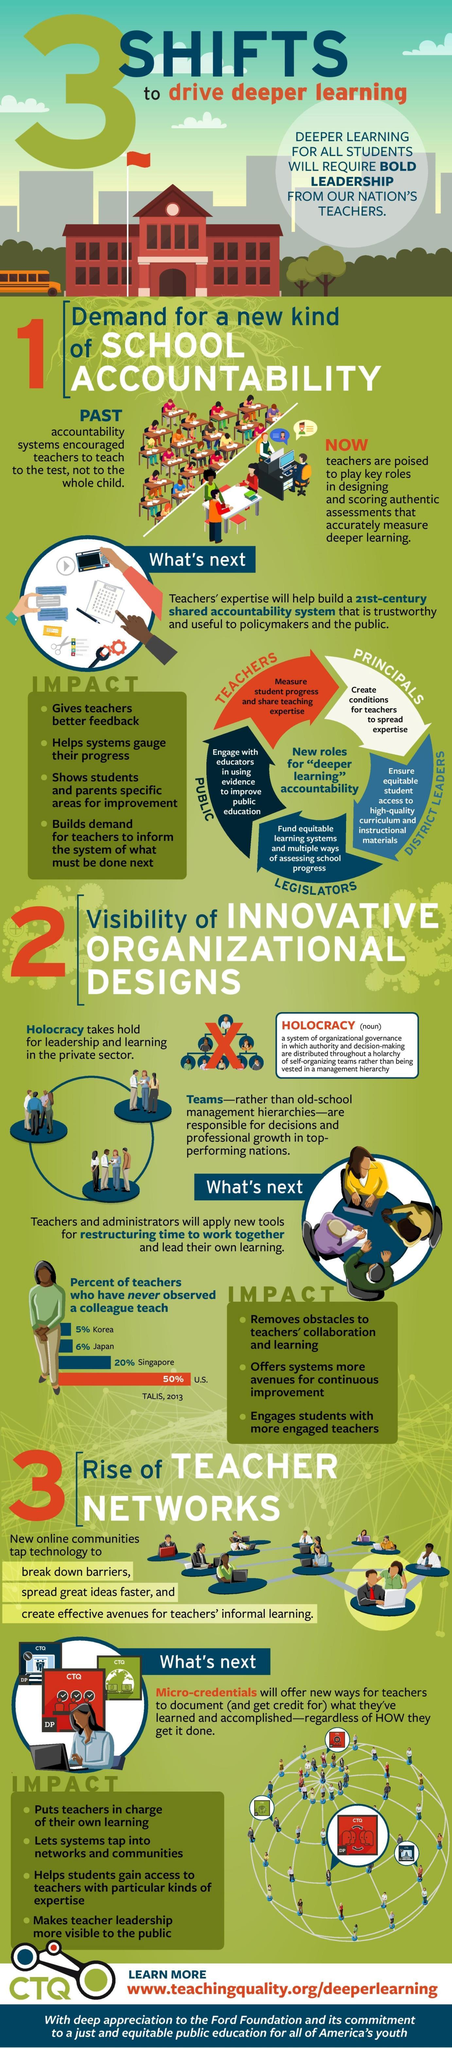What percent of teachers have never observed a colleague teach in U.S according to TALIS, 2013?
Answer the question with a short phrase. 50% What percent of teachers have never observed a colleague teach in Japan according to TALIS, 2013? 6% Who is responsible to fund equitable learning systems & multiple ways of assessing school progress? LEGISLATORS What percent of teachers have never observed a colleague teach in Singapore according to TALIS, 2013? 20% Who is responsible to measure student progress and share teaching expertise? TEACHERS Who is responsible to create conditions for teachers to spread expertise? PRINCIPALS Who is responsible to ensure equitable student access to high-quality curriculum & instructional materials? DISTRICT LEADERS 